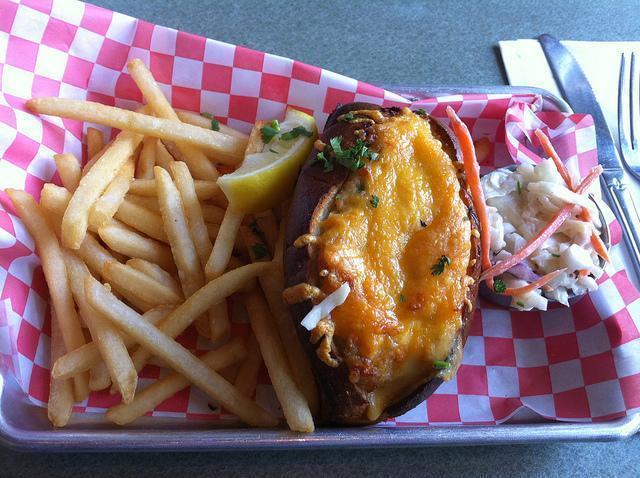Which food item on the plate is highest in fat?
Choose the right answer from the provided options to respond to the question.
Options: Cheese, coleslaw, potato skin, french fries. Cheese. 